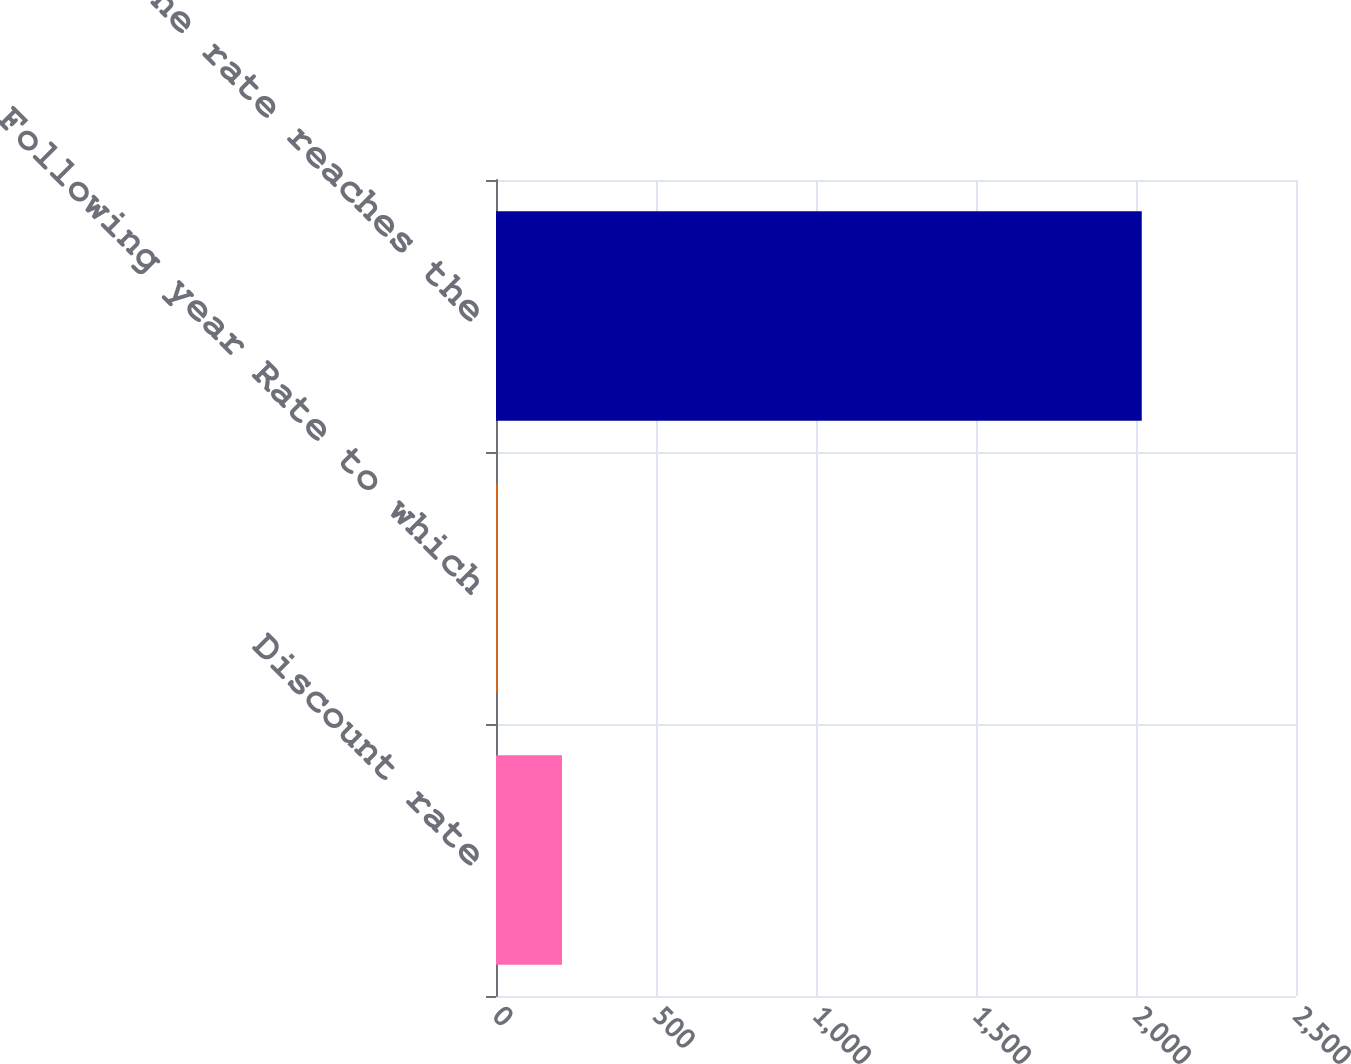<chart> <loc_0><loc_0><loc_500><loc_500><bar_chart><fcel>Discount rate<fcel>Following year Rate to which<fcel>Year that the rate reaches the<nl><fcel>206.3<fcel>5<fcel>2018<nl></chart> 